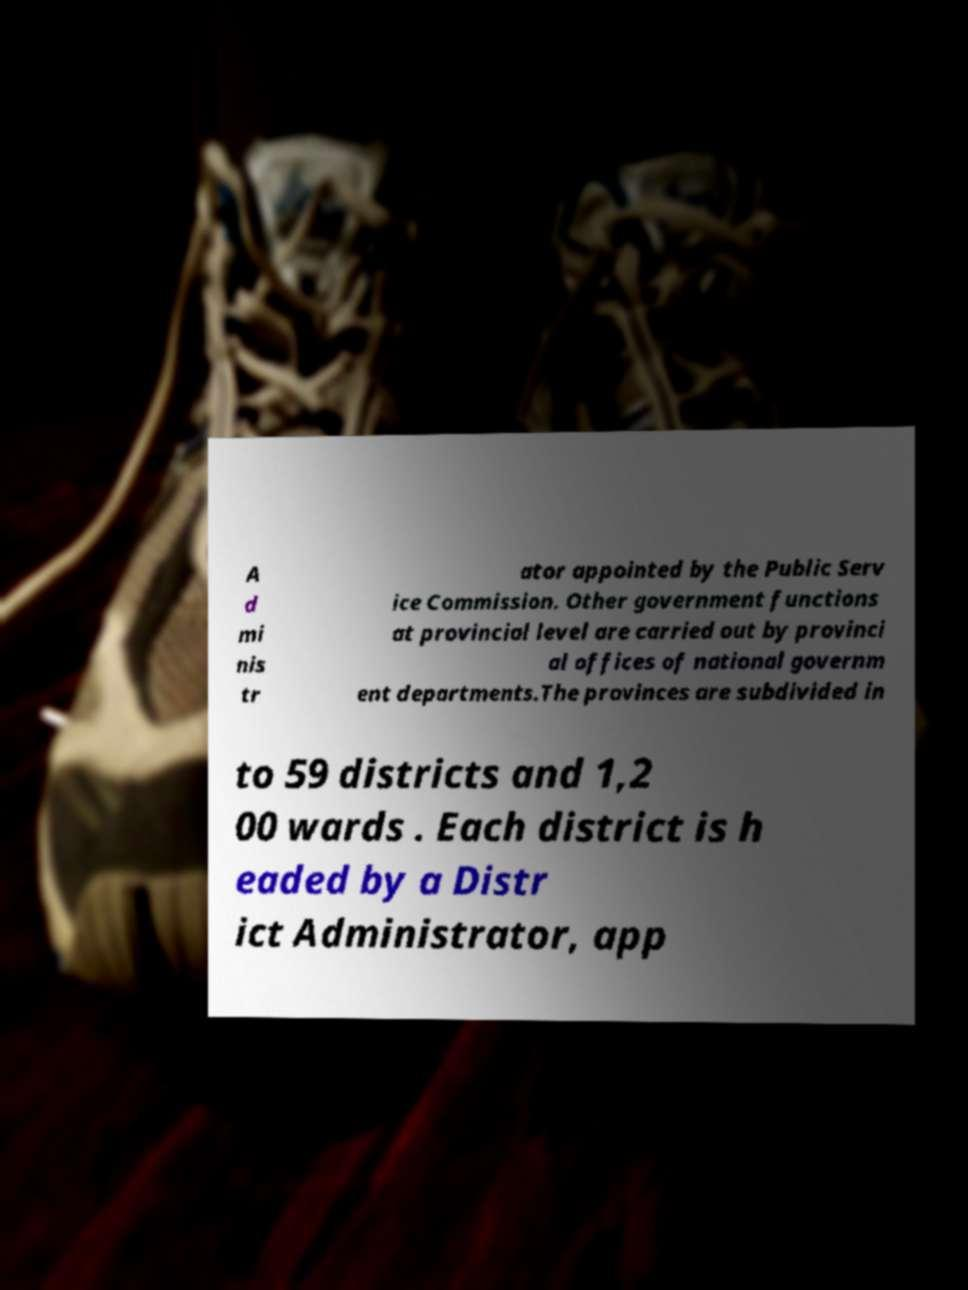Please identify and transcribe the text found in this image. A d mi nis tr ator appointed by the Public Serv ice Commission. Other government functions at provincial level are carried out by provinci al offices of national governm ent departments.The provinces are subdivided in to 59 districts and 1,2 00 wards . Each district is h eaded by a Distr ict Administrator, app 